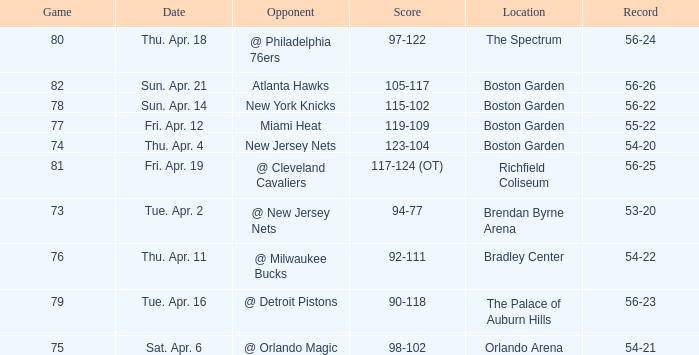Where was game 78 held? Boston Garden. 